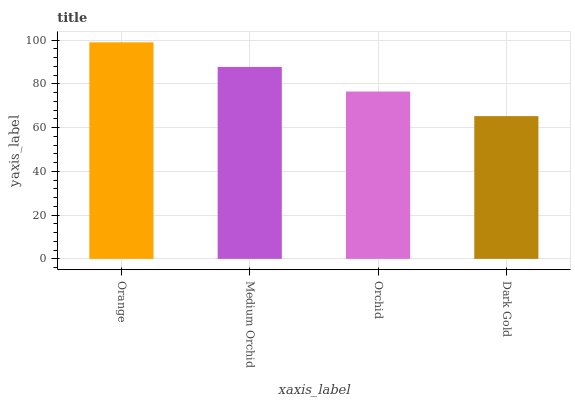Is Medium Orchid the minimum?
Answer yes or no. No. Is Medium Orchid the maximum?
Answer yes or no. No. Is Orange greater than Medium Orchid?
Answer yes or no. Yes. Is Medium Orchid less than Orange?
Answer yes or no. Yes. Is Medium Orchid greater than Orange?
Answer yes or no. No. Is Orange less than Medium Orchid?
Answer yes or no. No. Is Medium Orchid the high median?
Answer yes or no. Yes. Is Orchid the low median?
Answer yes or no. Yes. Is Orange the high median?
Answer yes or no. No. Is Orange the low median?
Answer yes or no. No. 